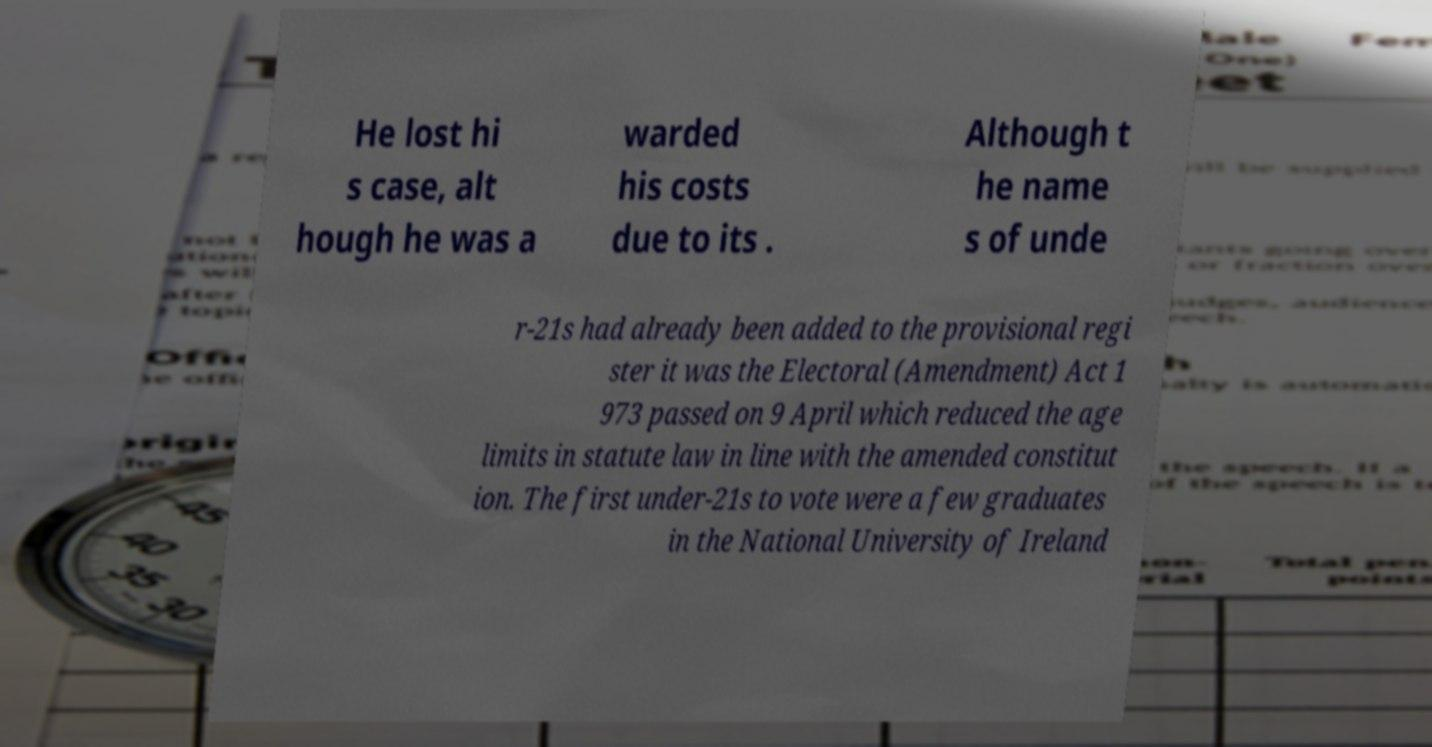Could you extract and type out the text from this image? He lost hi s case, alt hough he was a warded his costs due to its . Although t he name s of unde r-21s had already been added to the provisional regi ster it was the Electoral (Amendment) Act 1 973 passed on 9 April which reduced the age limits in statute law in line with the amended constitut ion. The first under-21s to vote were a few graduates in the National University of Ireland 